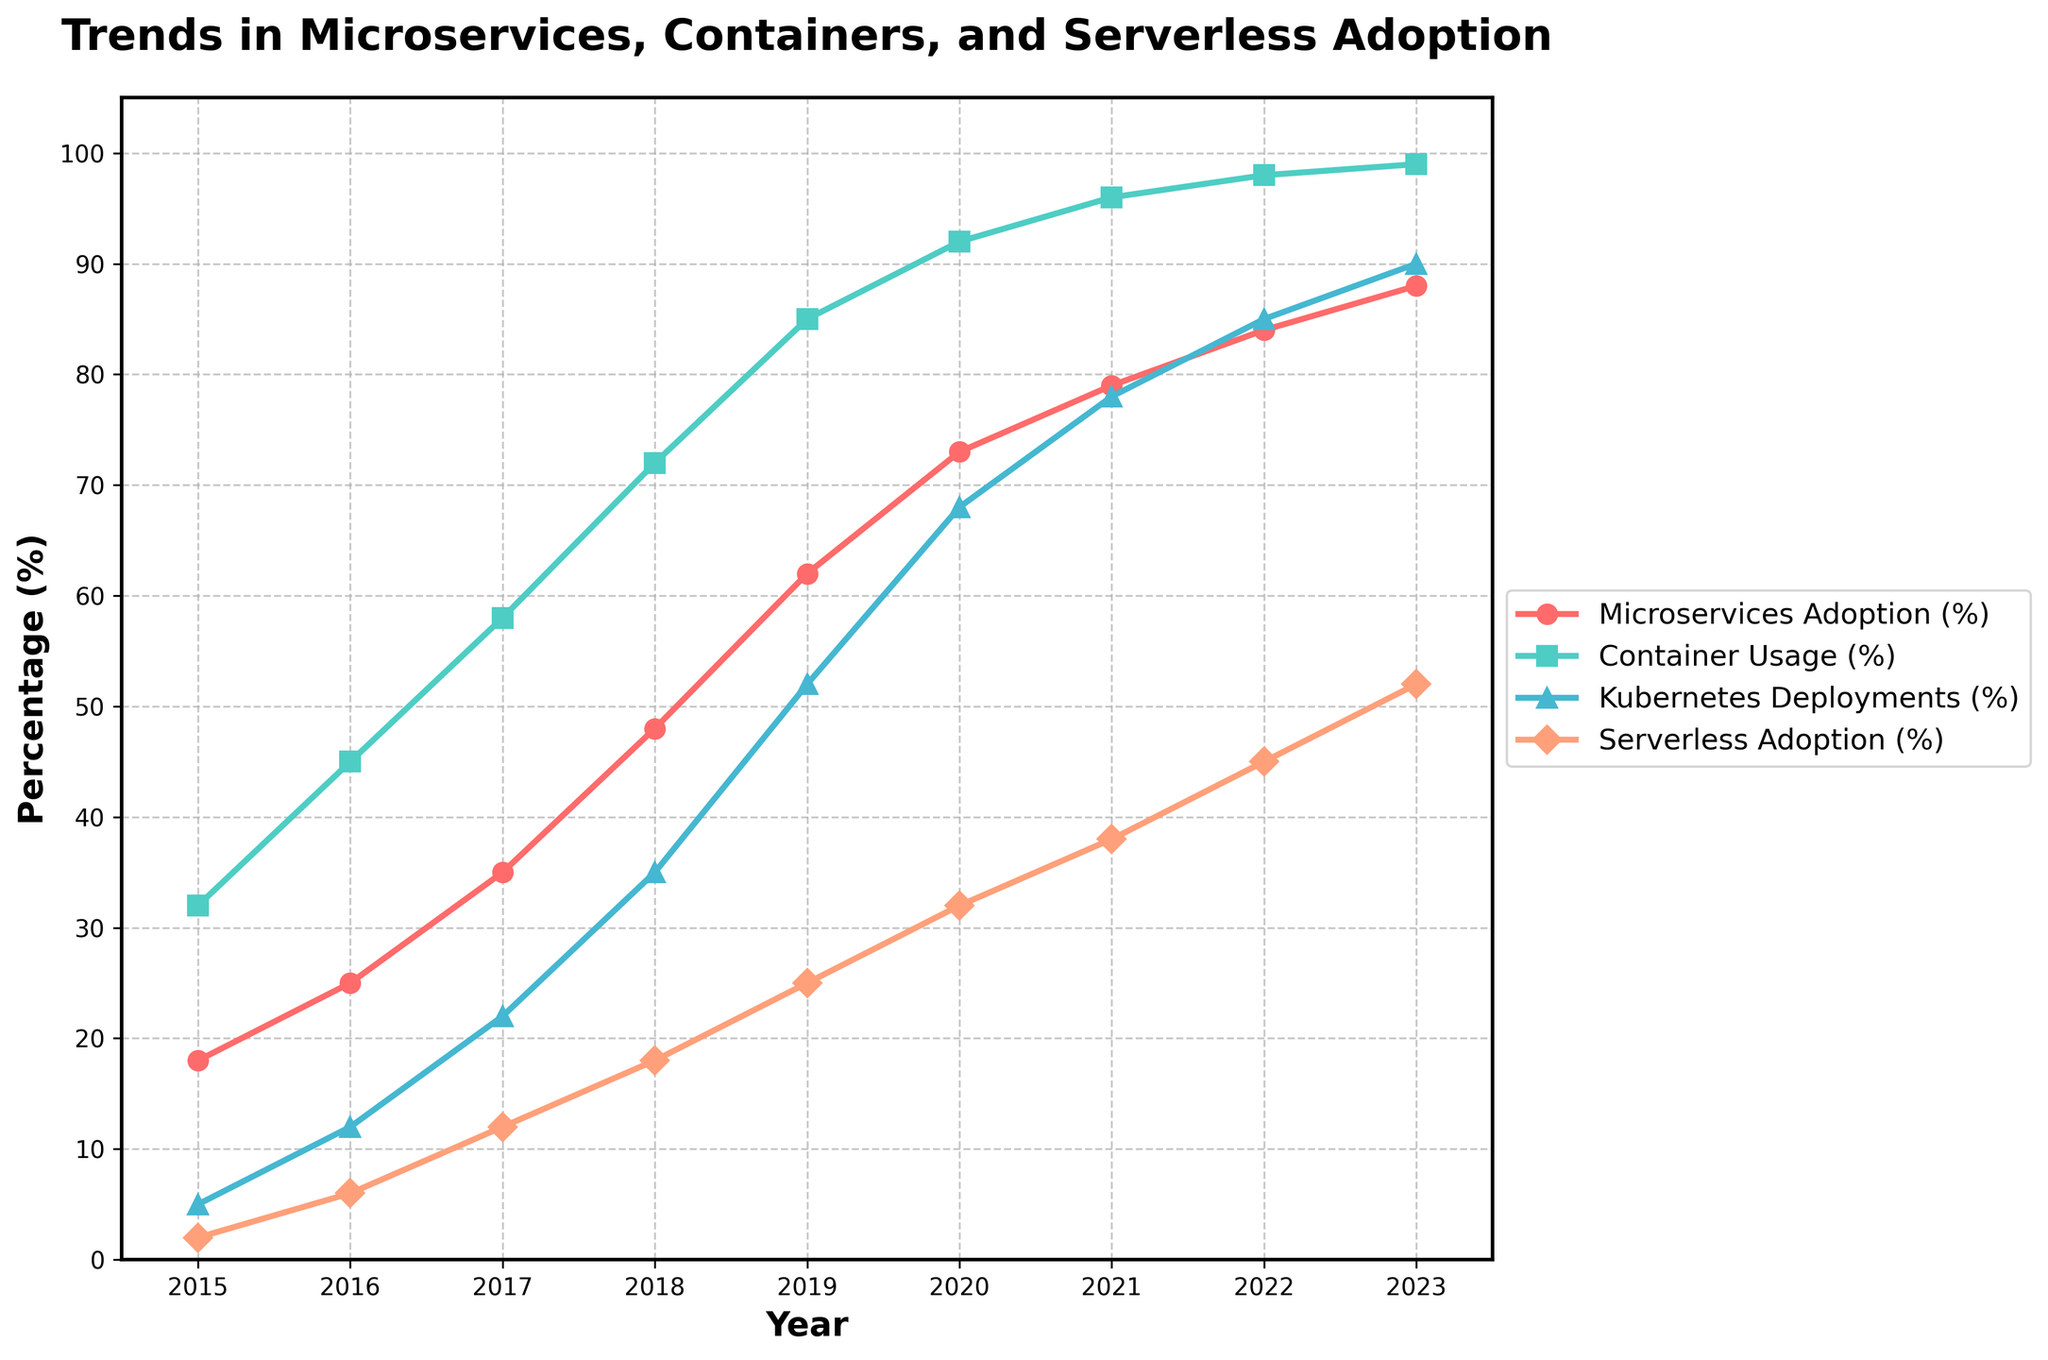What year saw the biggest increase in Microservices Adoption (%) compared to the previous year? To determine the year with the biggest increase, we calculate the difference in Microservices Adoption (%) for each year compared to the previous year. The differences are as follows: 2016 (25-18)=7, 2017 (35-25)=10, 2018 (48-35)=13, 2019 (62-48)=14, 2020 (73-62)=11, 2021 (79-73)=6, 2022 (84-79)=5, 2023 (88-84)=4. The largest difference is 14 in 2019.
Answer: 2019 By how much did Container Usage (%) increase from 2015 to 2020? We find the Container Usage (%) for 2015 and 2020 from the chart, which are 32% and 92%, respectively. The increase is 92 - 32 = 60%.
Answer: 60% Which year had the highest Serverless Adoption (%) and what was the percentage? From the chart, the percentages for Serverless Adoption (%) in the last year, 2023, are the highest at 52%.
Answer: 2023, 52% What trend can you observe for Kubernetes Deployments (%) from 2015 to 2023? Observing the graph lines, Kubernetes Deployments (%) have steadily increased each year, starting from 5% in 2015 to reaching 90% in 2023.
Answer: Steady increase Which two metrics have the closest values in the year 2021? In 2021, the values are: Microservices Adoption (79%), Container Usage (96%), Kubernetes Deployments (78%), Serverless Adoption (38%). The closest values are Microservices Adoption (79%) and Kubernetes Deployments (78%).
Answer: Microservices Adoption and Kubernetes Deployments Comparing the percentage increase, which has grown faster between 2015 and 2023: Microservices Adoption (%) or Kubernetes Deployments (%)? To compare the growth, calculate the increase for each metric: Microservices Adoption increased from 18% to 88%, which is an increase of 70%. Kubernetes Deployments increased from 5% to 90%, which is an increase of 85%. Kubernetes Deployments grew faster.
Answer: Kubernetes Deployments What color line represents the Container Usage (%) in the graph? Observing the color of the line corresponding to Container Usage (%), it is shown in green.
Answer: Green By how much did Serverless Adoption (%) and Kubernetes Deployments (%) collectively rise from 2016 to 2019? Calculating the increase for both metrics, we have: Serverless Adoption: 25% (2019) - 6% (2016) = 19%, Kubernetes Deployments: 52% (2019) - 12% (2016) = 40%. Collectively, the increase is 19% + 40% = 59%.
Answer: 59% How does Microservices Adoption (%) in 2020 compare to Container Usage (%) in 2017? Checking the values in the given years, Microservices Adoption in 2020 is 73% and Container Usage in 2017 is 58%. Microservices Adoption in 2020 is higher.
Answer: 73% vs 58% 